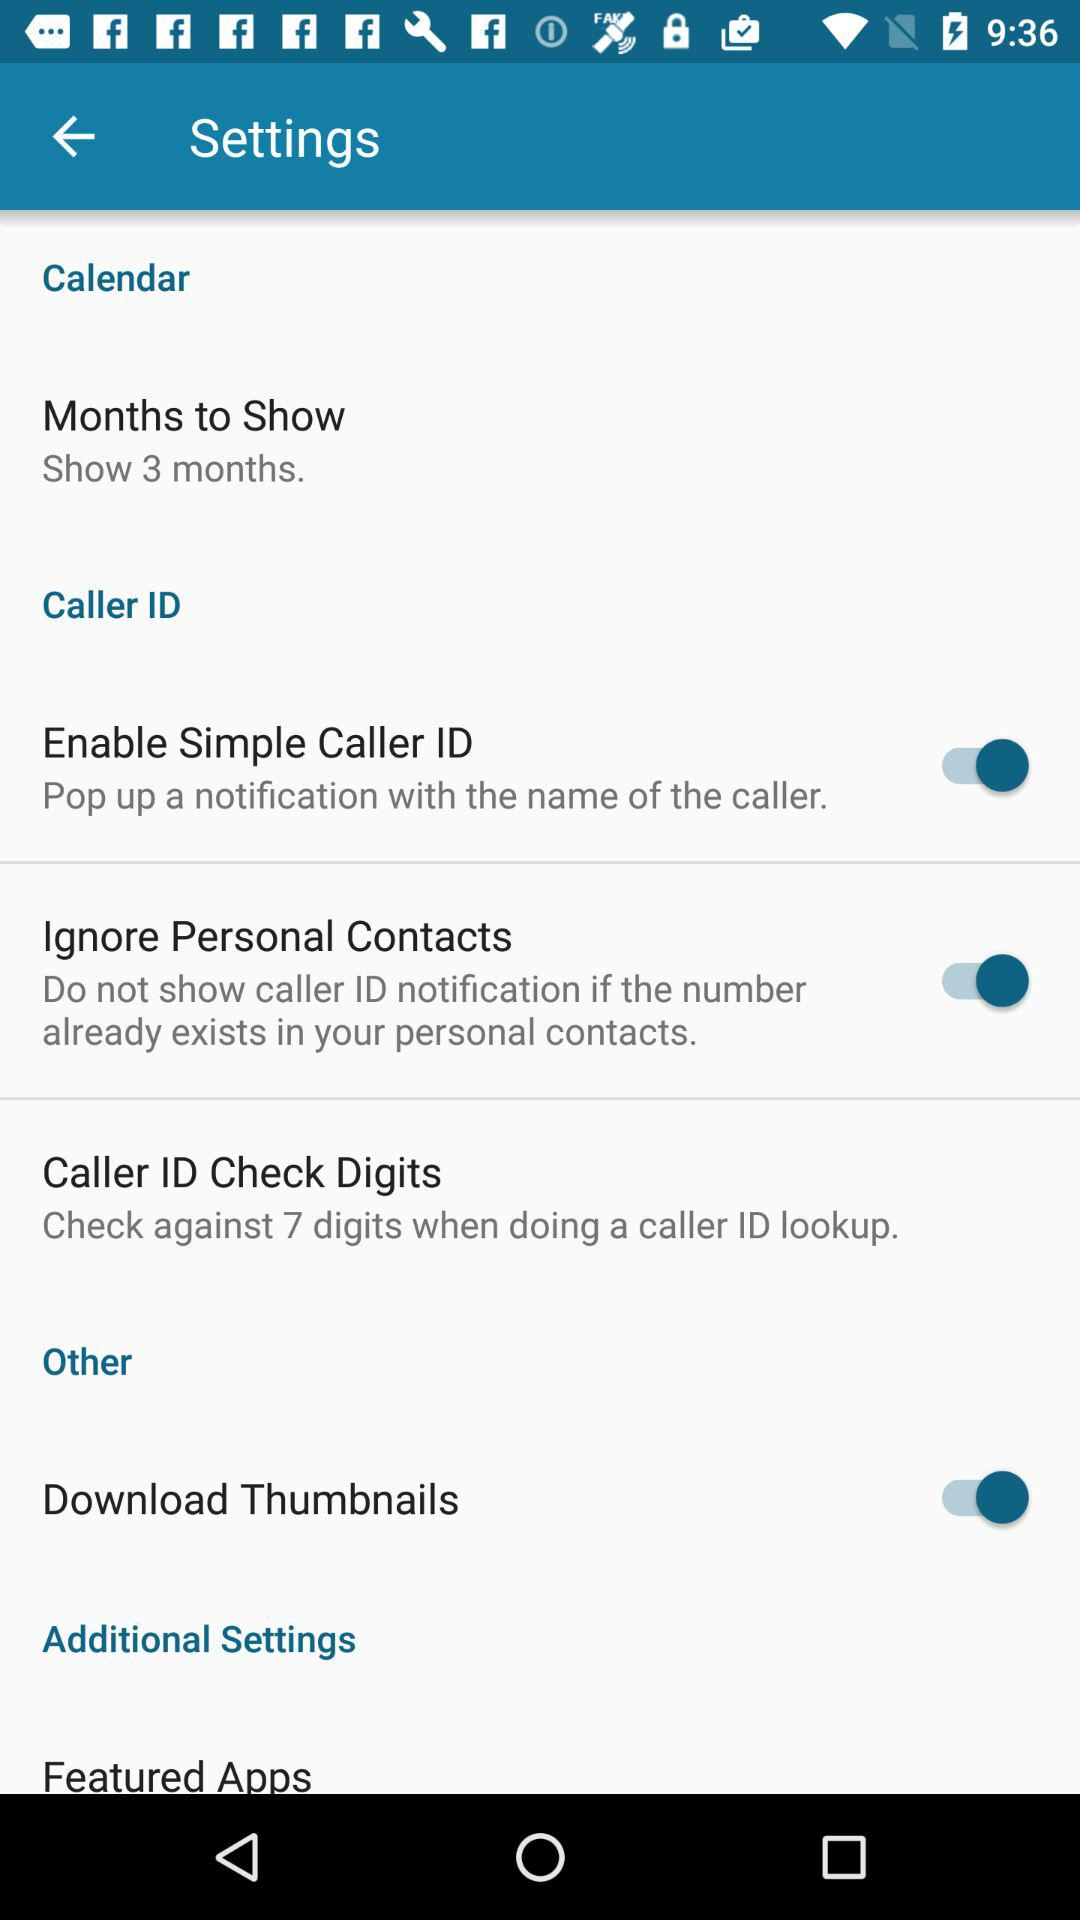When will the caller ID notification not be shown? The caller ID notification will not be shown if the number already exists in your personal contacts. 